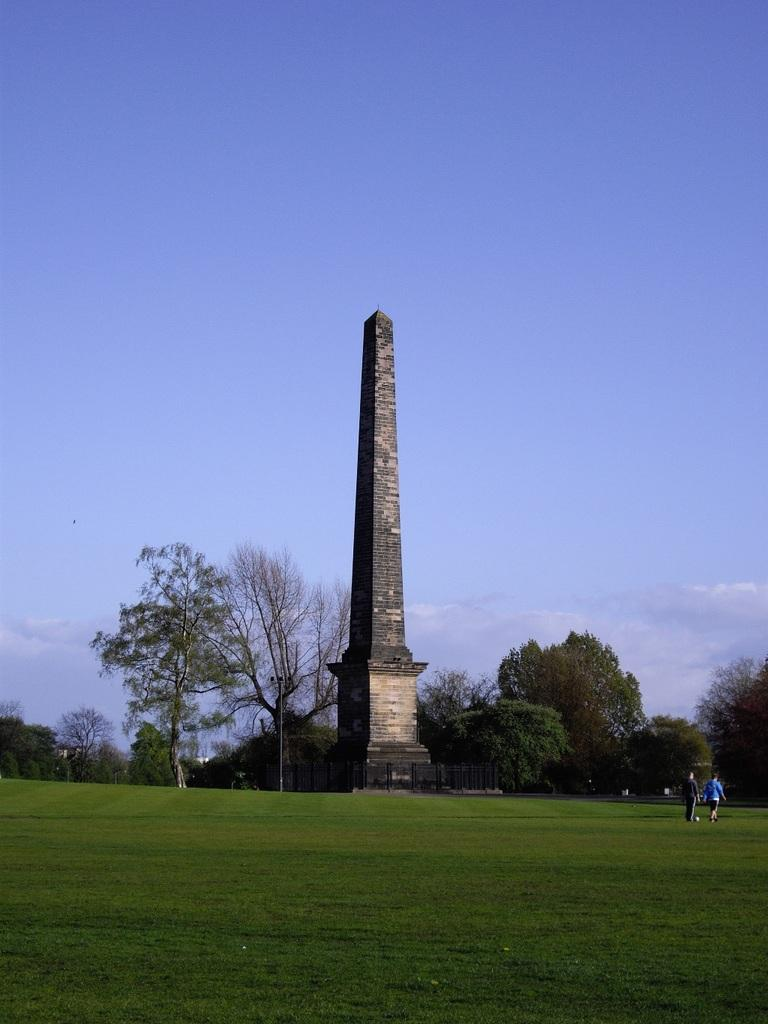What is the main structure in the image? There is a tower in the image. What type of vegetation can be seen in the image? There is grass and trees in the image. What other objects are present in the image? There is a pole and a fence in the image. How many people are in the image? There are two persons on the ground in the image. What is visible in the background of the image? The sky is visible in the background of the image. What type of noise is the cow making in the image? There is no cow present in the image, so it is not possible to determine the type of noise it might be making. What type of destruction is visible in the image? There is no destruction present in the image; it features a tower, grass, trees, a pole, a fence, and two people. 